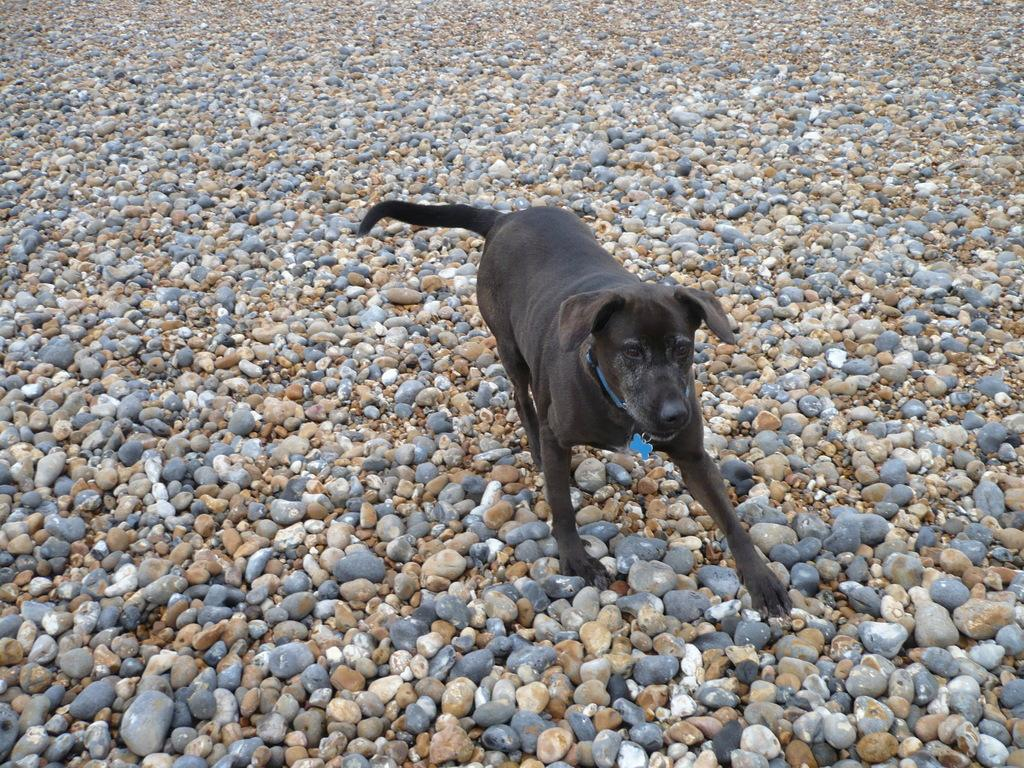What type of animal is in the image? There is a dog in the image. What color is the dog? The dog is black in color. What can be seen at the bottom of the image? There are stones at the bottom of the image. How many colors do the stones have? The stones have different colors. Is the dog experiencing any pain in the image? There is no indication of pain in the image; the dog appears to be standing still. How many pins can be seen holding the turkey in the image? There is no turkey or pins present in the image. 